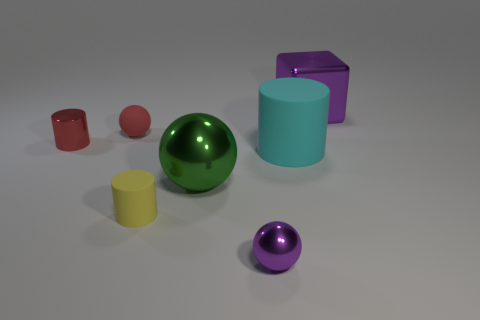What shape is the yellow matte object? The yellow matte object in the image is cylindrical in shape, with its circular base sitting squarely on the surface, and its smooth sides extending vertically to form its height. 